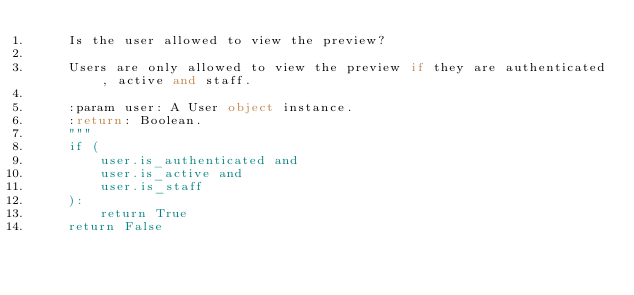Convert code to text. <code><loc_0><loc_0><loc_500><loc_500><_Python_>    Is the user allowed to view the preview?

    Users are only allowed to view the preview if they are authenticated, active and staff.

    :param user: A User object instance.
    :return: Boolean.
    """
    if (
        user.is_authenticated and
        user.is_active and
        user.is_staff
    ):
        return True
    return False
</code> 